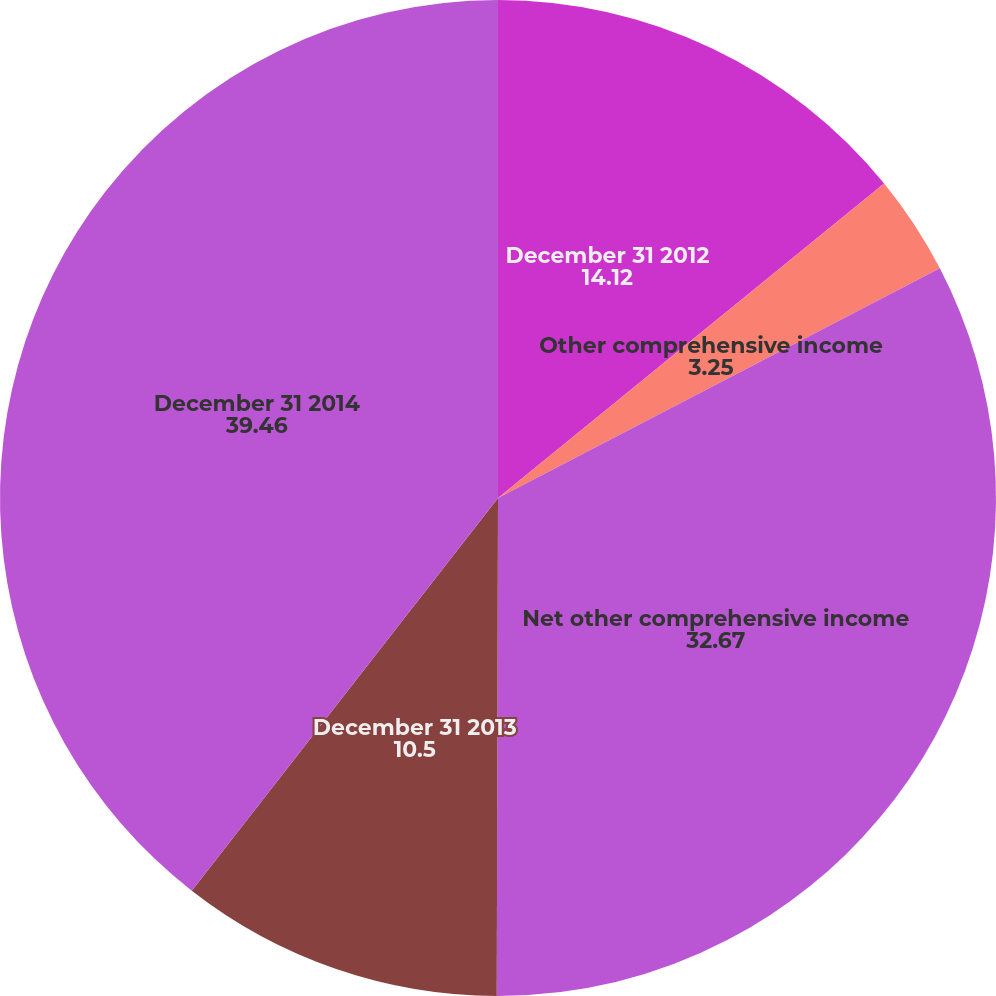Convert chart to OTSL. <chart><loc_0><loc_0><loc_500><loc_500><pie_chart><fcel>December 31 2012<fcel>Other comprehensive income<fcel>Net other comprehensive income<fcel>December 31 2013<fcel>December 31 2014<nl><fcel>14.12%<fcel>3.25%<fcel>32.67%<fcel>10.5%<fcel>39.46%<nl></chart> 